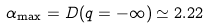<formula> <loc_0><loc_0><loc_500><loc_500>\alpha _ { \max } = D ( q = - \infty ) \simeq 2 . 2 2</formula> 